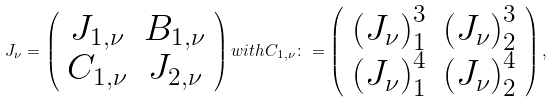<formula> <loc_0><loc_0><loc_500><loc_500>J _ { \nu } = \left ( \begin{array} { c c c c c } J _ { 1 , \nu } & B _ { 1 , \nu } \\ C _ { 1 , \nu } & J _ { 2 , \nu } \\ \end{array} \right ) w i t h C _ { 1 , \nu } \colon = \left ( \begin{array} { c c c c c } \left ( J _ { \nu } \right ) _ { 1 } ^ { 3 } & \left ( J _ { \nu } \right ) _ { 2 } ^ { 3 } \\ \left ( J _ { \nu } \right ) _ { 1 } ^ { 4 } & \left ( J _ { \nu } \right ) _ { 2 } ^ { 4 } \\ \end{array} \right ) ,</formula> 